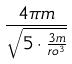Convert formula to latex. <formula><loc_0><loc_0><loc_500><loc_500>\frac { 4 \pi m } { \sqrt { 5 \cdot \frac { 3 m } { r o ^ { 3 } } } }</formula> 